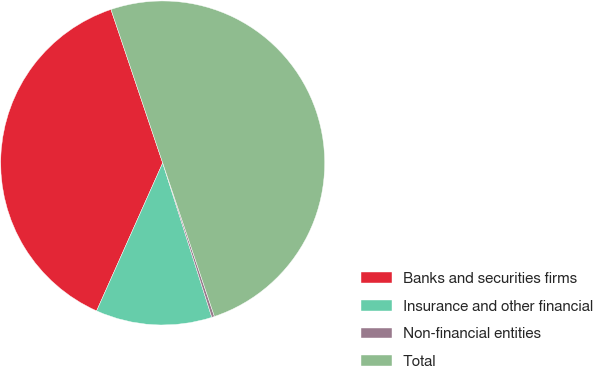Convert chart. <chart><loc_0><loc_0><loc_500><loc_500><pie_chart><fcel>Banks and securities firms<fcel>Insurance and other financial<fcel>Non-financial entities<fcel>Total<nl><fcel>38.14%<fcel>11.59%<fcel>0.27%<fcel>50.0%<nl></chart> 